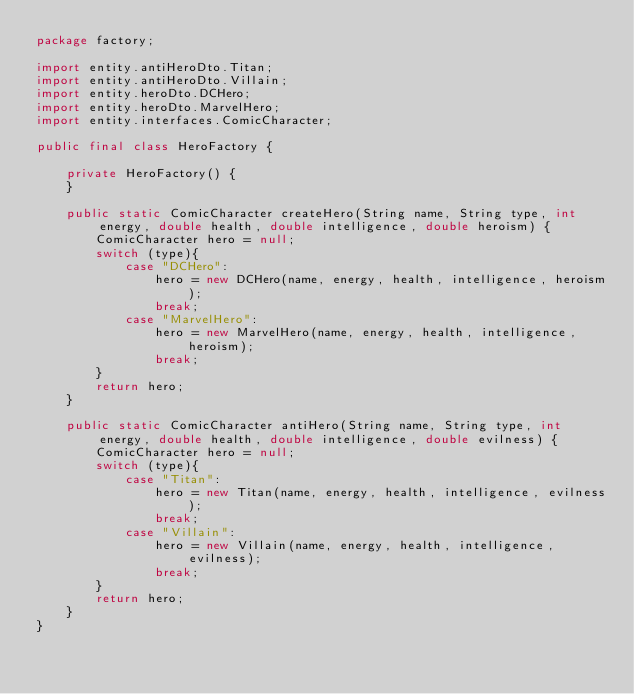Convert code to text. <code><loc_0><loc_0><loc_500><loc_500><_Java_>package factory;

import entity.antiHeroDto.Titan;
import entity.antiHeroDto.Villain;
import entity.heroDto.DCHero;
import entity.heroDto.MarvelHero;
import entity.interfaces.ComicCharacter;

public final class HeroFactory {

    private HeroFactory() {
    }

    public static ComicCharacter createHero(String name, String type, int energy, double health, double intelligence, double heroism) {
        ComicCharacter hero = null;
        switch (type){
            case "DCHero":
                hero = new DCHero(name, energy, health, intelligence, heroism);
                break;
            case "MarvelHero":
                hero = new MarvelHero(name, energy, health, intelligence, heroism);
                break;
        }
        return hero;
    }

    public static ComicCharacter antiHero(String name, String type, int energy, double health, double intelligence, double evilness) {
        ComicCharacter hero = null;
        switch (type){
            case "Titan":
                hero = new Titan(name, energy, health, intelligence, evilness);
                break;
            case "Villain":
                hero = new Villain(name, energy, health, intelligence, evilness);
                break;
        }
        return hero;
    }
}
</code> 